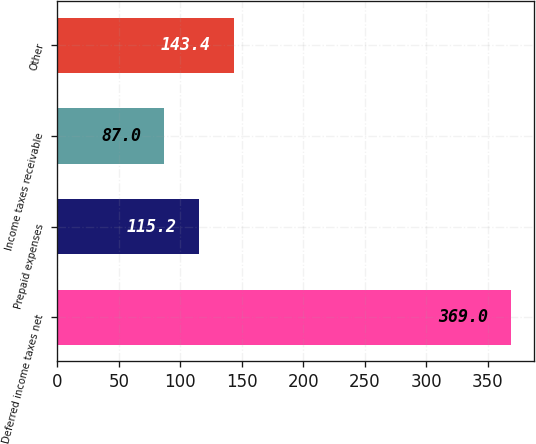<chart> <loc_0><loc_0><loc_500><loc_500><bar_chart><fcel>Deferred income taxes net<fcel>Prepaid expenses<fcel>Income taxes receivable<fcel>Other<nl><fcel>369<fcel>115.2<fcel>87<fcel>143.4<nl></chart> 